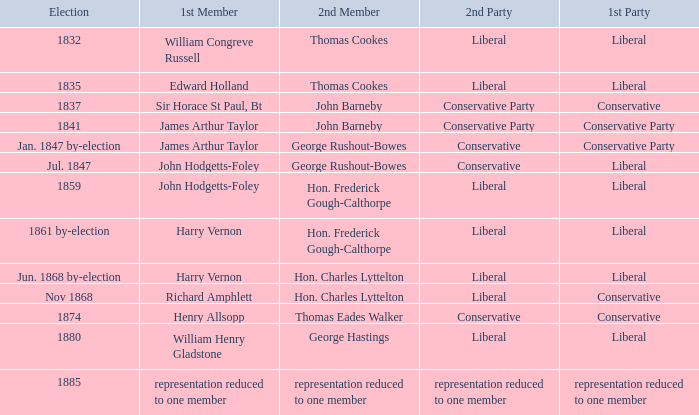What was the 2nd Party when its 2nd Member was George Rushout-Bowes, and the 1st Party was Liberal? Conservative. 